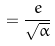<formula> <loc_0><loc_0><loc_500><loc_500>= \frac { e } { \sqrt { \alpha } }</formula> 